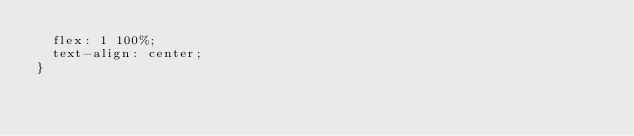Convert code to text. <code><loc_0><loc_0><loc_500><loc_500><_CSS_>  flex: 1 100%;
  text-align: center;
}
</code> 